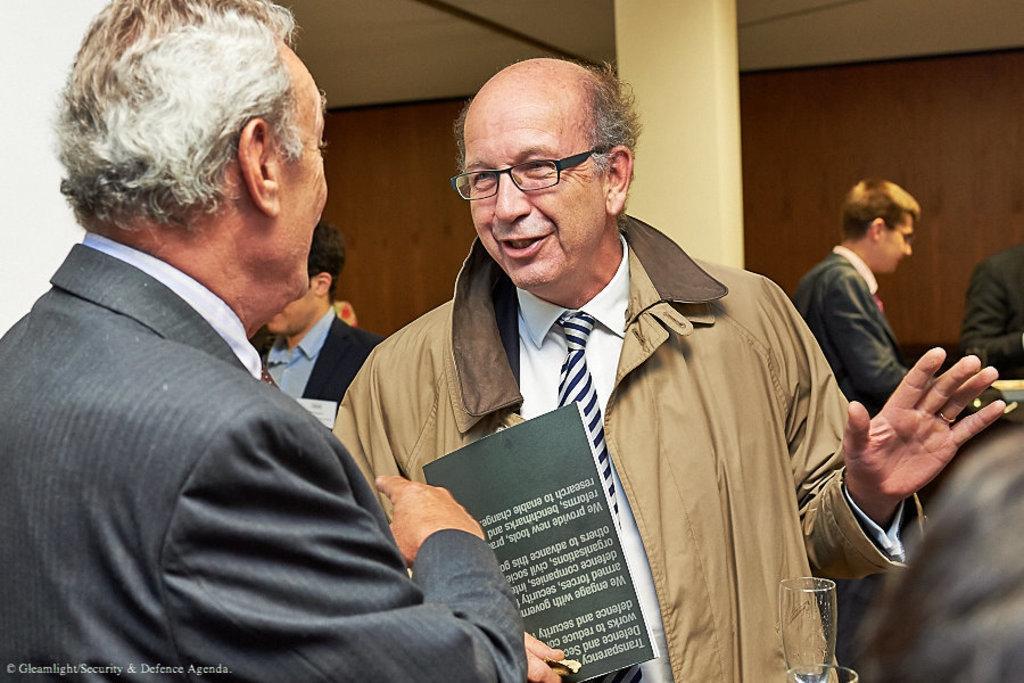Please provide a concise description of this image. In this image there are a few men standing. The man in the center is holding a book in his hand. Behind him there is a pillar. In the background there is a wall. At the top there is a ceiling. 